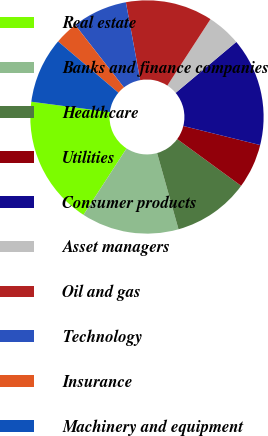<chart> <loc_0><loc_0><loc_500><loc_500><pie_chart><fcel>Real estate<fcel>Banks and finance companies<fcel>Healthcare<fcel>Utilities<fcel>Consumer products<fcel>Asset managers<fcel>Oil and gas<fcel>Technology<fcel>Insurance<fcel>Machinery and equipment<nl><fcel>17.93%<fcel>13.52%<fcel>10.59%<fcel>6.18%<fcel>14.99%<fcel>4.71%<fcel>12.06%<fcel>7.65%<fcel>3.25%<fcel>9.12%<nl></chart> 